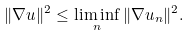Convert formula to latex. <formula><loc_0><loc_0><loc_500><loc_500>\| \nabla u \| ^ { 2 } \leq \liminf _ { n } \| \nabla u _ { n } \| ^ { 2 } .</formula> 